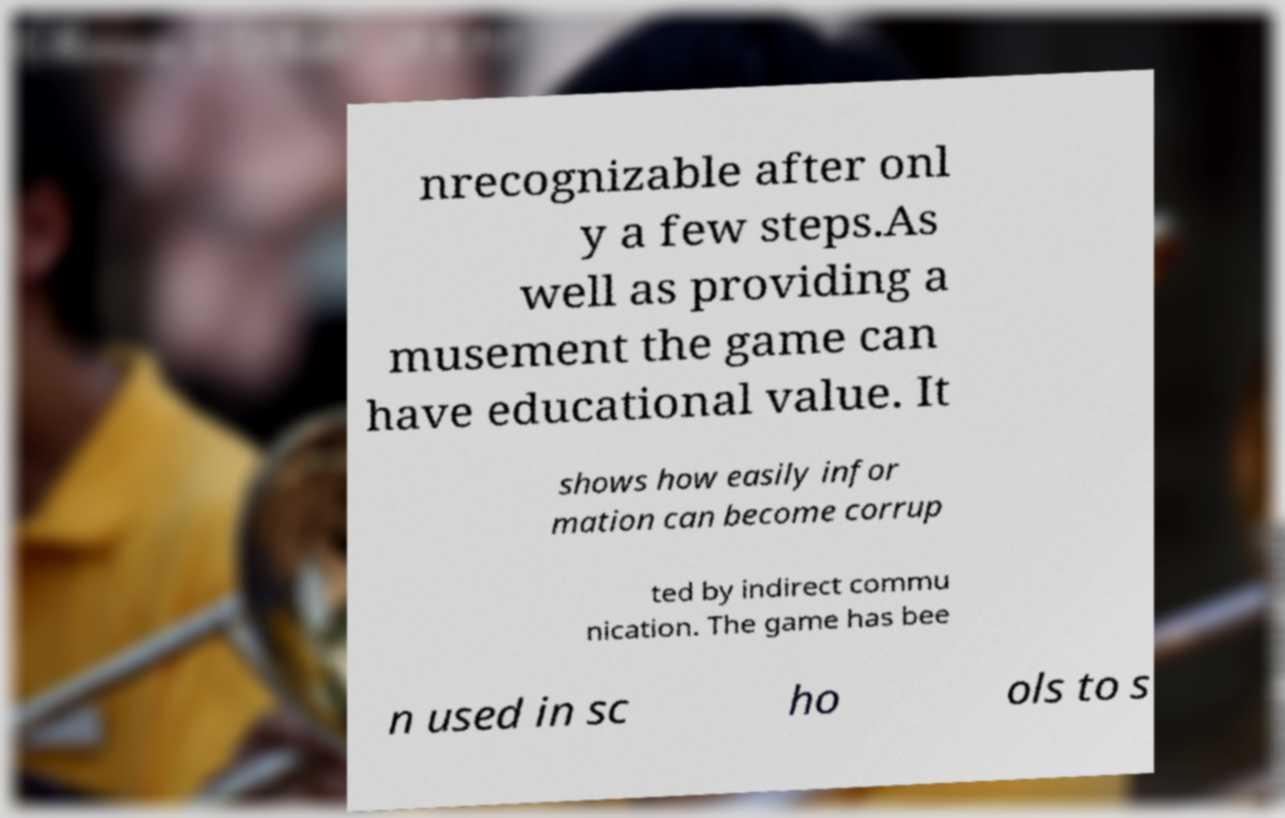I need the written content from this picture converted into text. Can you do that? nrecognizable after onl y a few steps.As well as providing a musement the game can have educational value. It shows how easily infor mation can become corrup ted by indirect commu nication. The game has bee n used in sc ho ols to s 